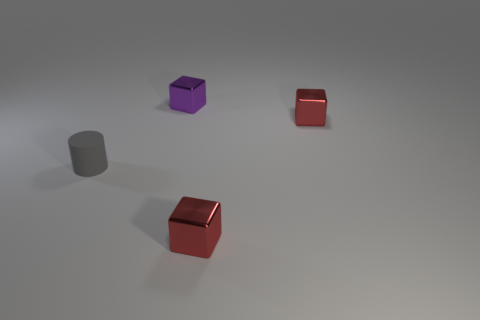Is there anything else that is made of the same material as the cylinder?
Your response must be concise. No. The block in front of the tiny red metallic cube that is behind the small red cube in front of the gray matte cylinder is made of what material?
Your response must be concise. Metal. How many other things are the same shape as the gray rubber thing?
Ensure brevity in your answer.  0. What is the color of the thing that is in front of the small rubber object?
Give a very brief answer. Red. There is a red block behind the tiny metal object that is in front of the tiny matte cylinder; how many shiny things are on the left side of it?
Your answer should be very brief. 2. There is a tiny object that is on the left side of the purple metallic thing; what number of red shiny blocks are behind it?
Provide a succinct answer. 1. There is a tiny purple metallic thing; what number of shiny things are in front of it?
Offer a very short reply. 2. How many other things are the same size as the gray matte object?
Your answer should be very brief. 3. What shape is the small thing on the left side of the tiny purple shiny object?
Keep it short and to the point. Cylinder. There is a thing in front of the object that is left of the purple thing; what is its color?
Ensure brevity in your answer.  Red. 